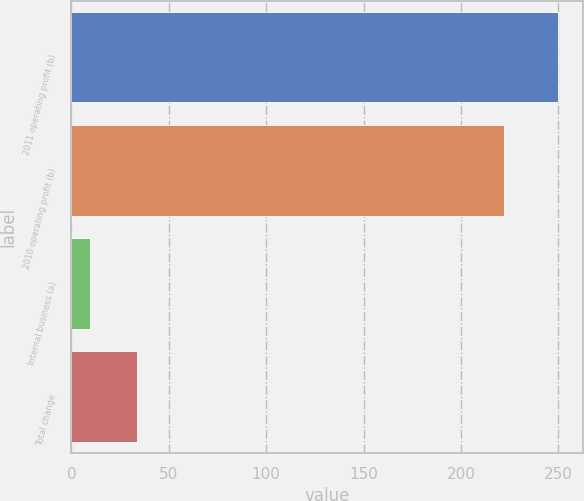<chart> <loc_0><loc_0><loc_500><loc_500><bar_chart><fcel>2011 operating profit (b)<fcel>2010 operating profit (b)<fcel>Internal business (a)<fcel>Total change<nl><fcel>250<fcel>222<fcel>9.5<fcel>33.55<nl></chart> 